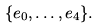Convert formula to latex. <formula><loc_0><loc_0><loc_500><loc_500>\{ e _ { 0 } , \dots , e _ { 4 } \} .</formula> 